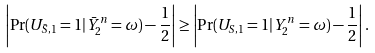<formula> <loc_0><loc_0><loc_500><loc_500>\left | \Pr ( U _ { \bar { S } , 1 } = 1 | { \bar { Y } } _ { 2 } ^ { n } = \omega ) - \frac { 1 } { 2 } \right | \geq \left | \Pr ( U _ { S , 1 } = 1 | Y _ { 2 } ^ { n } = \omega ) - \frac { 1 } { 2 } \right | .</formula> 